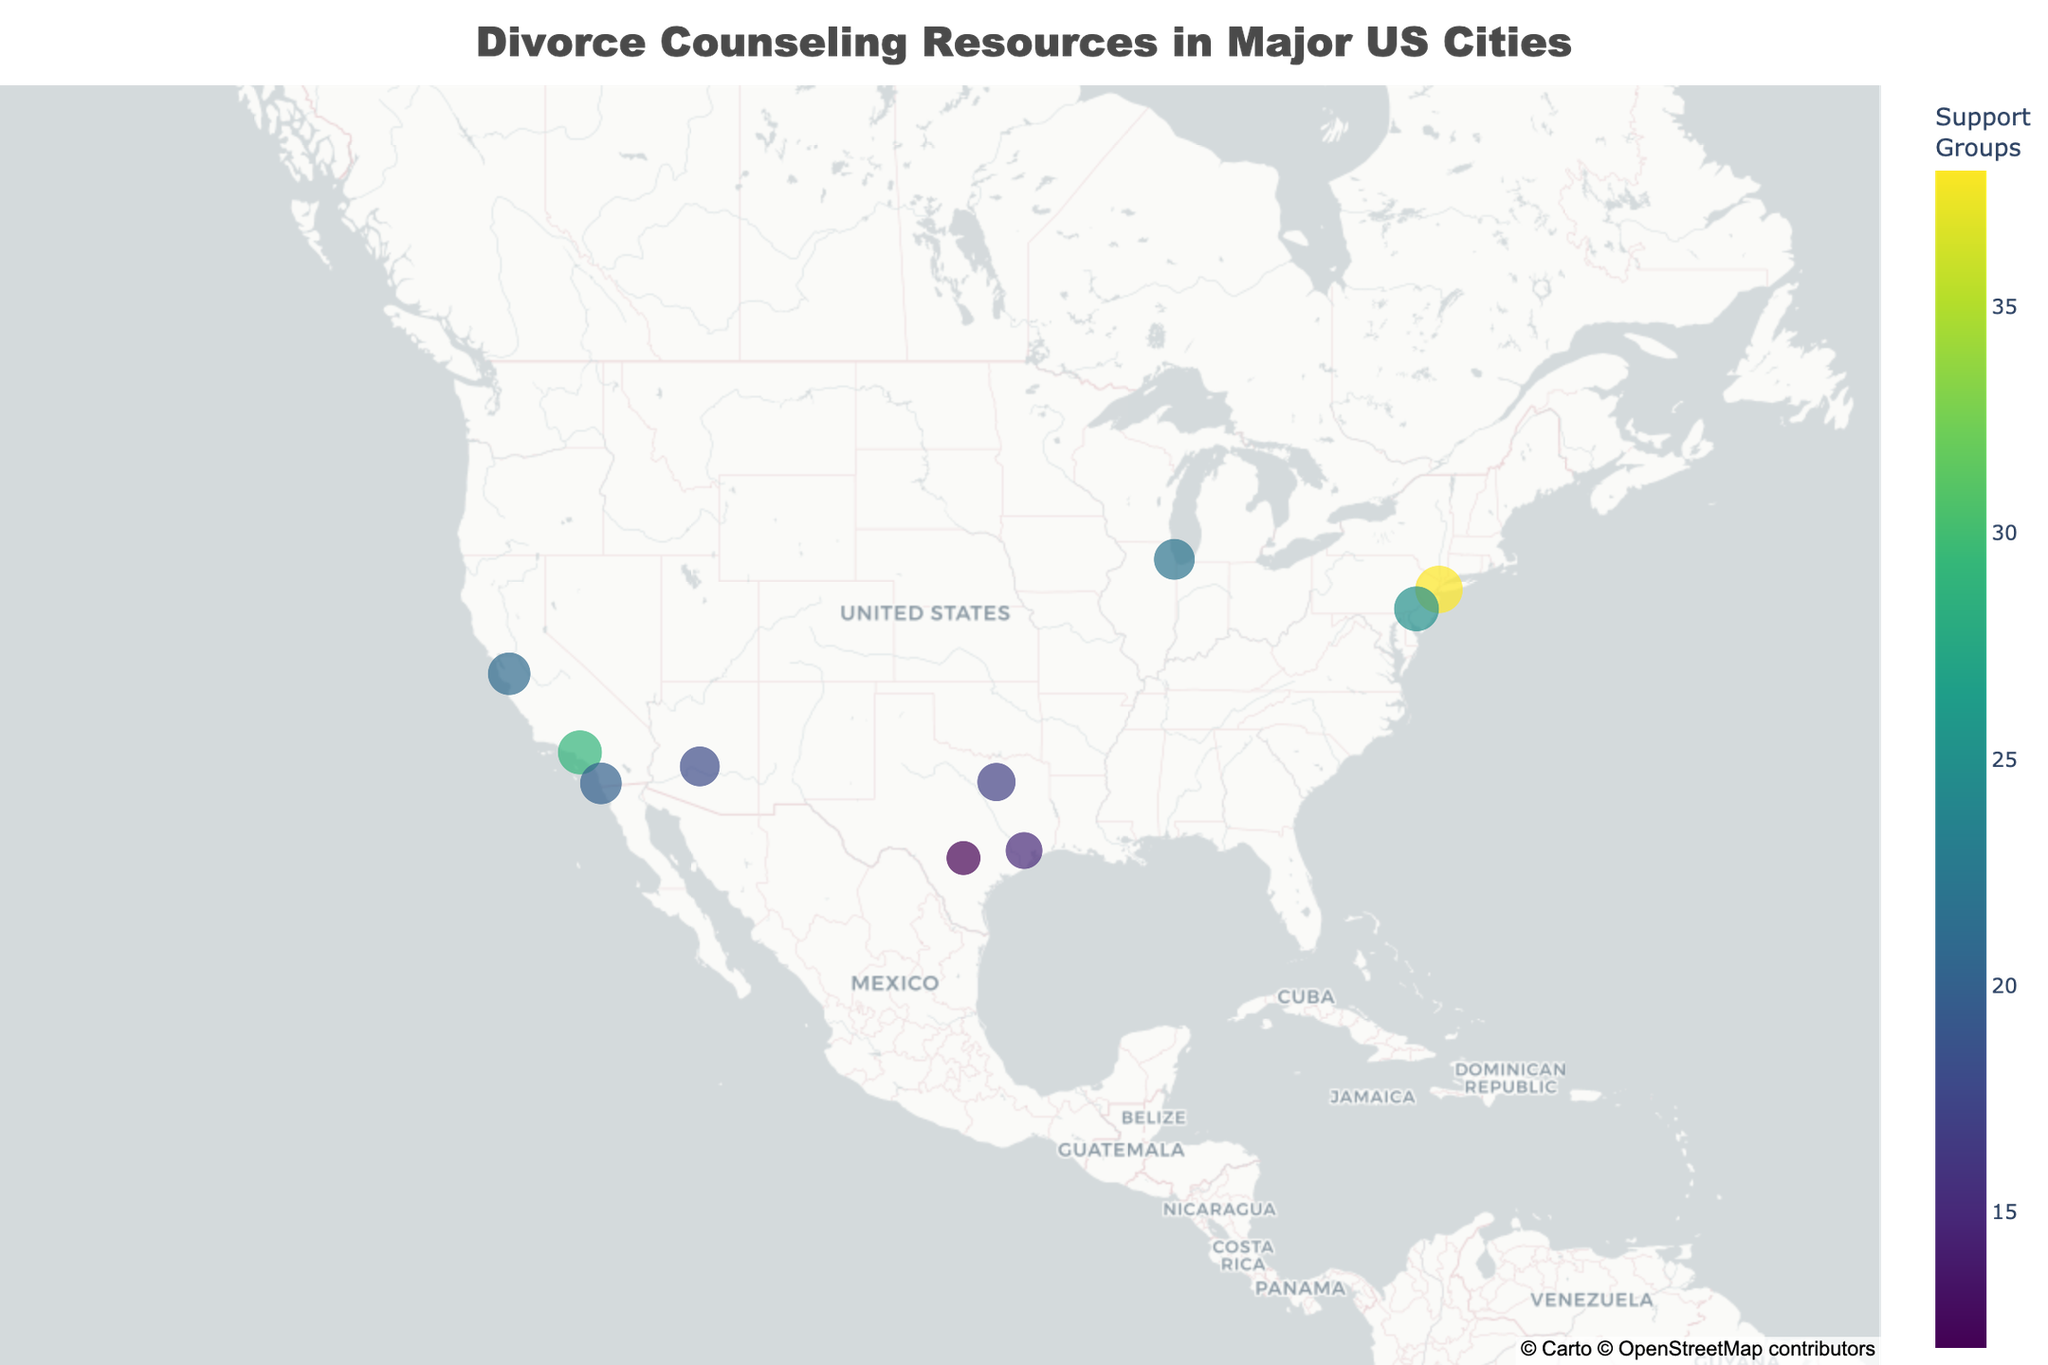Which city has the highest number of divorce counselors per 100k people? To find the city with the highest number of divorce counselors per 100k people, observe the size of the dots which represent this metric. The largest dot corresponds to New York.
Answer: New York What is the color scale representing on the map? The color scale on the map represents the number of support groups in each city, with darker colors indicating more support groups.
Answer: Number of support groups How many support groups are in Philadelphia? Hover over the dot representing Philadelphia and you will see the count of support groups in the city.
Answer: 25 Which city has the smallest size dot and what does it represent? Identify the smallest dot on the map, which corresponds to San Antonio. This indicates the number of divorce counselors per 100k people, which is the lowest in the dataset at 6.5.
Answer: San Antonio How does the number of divorce counselors per 100k in Los Angeles compare to Chicago? Check the sizes of the dots for Los Angeles and Chicago. Los Angeles has a dot size representing 10.8, whereas Chicago's dot size represents 9.3.
Answer: Los Angeles has more Which cities have more than 20 support groups? Hover over the dots and check the support group counts. The cities with more than 20 support groups are New York, Los Angeles, Philadelphia, and Chicago.
Answer: New York, Los Angeles, Philadelphia, Chicago What is the support group count difference between Houston and San Diego? Find the support group counts for both cities by hovering over their dots; Houston has 15 and San Diego has 20. Subtract to find the difference (20 - 15).
Answer: 5 What is the average number of divorce counselors per 100k across all cities? Sum all the provided 'Divorce Counselors per 100k' values and divide by the total number of cities. (12.5 + 10.8 + 9.3 + 7.6 + 8.9 + 11.2 + 6.5 + 9.7 + 8.2 + 10.1) / 10 = 9.48
Answer: 9.48 Which city has the highest density of divorce counselors per 100k and the lowest number of support groups? Identify the cities with the highest and lowest values by examining the dot sizes and colors; New York has the highest counselors density (12.5) and San Antonio has the lowest support groups (12).
Answer: New York and San Antonio 